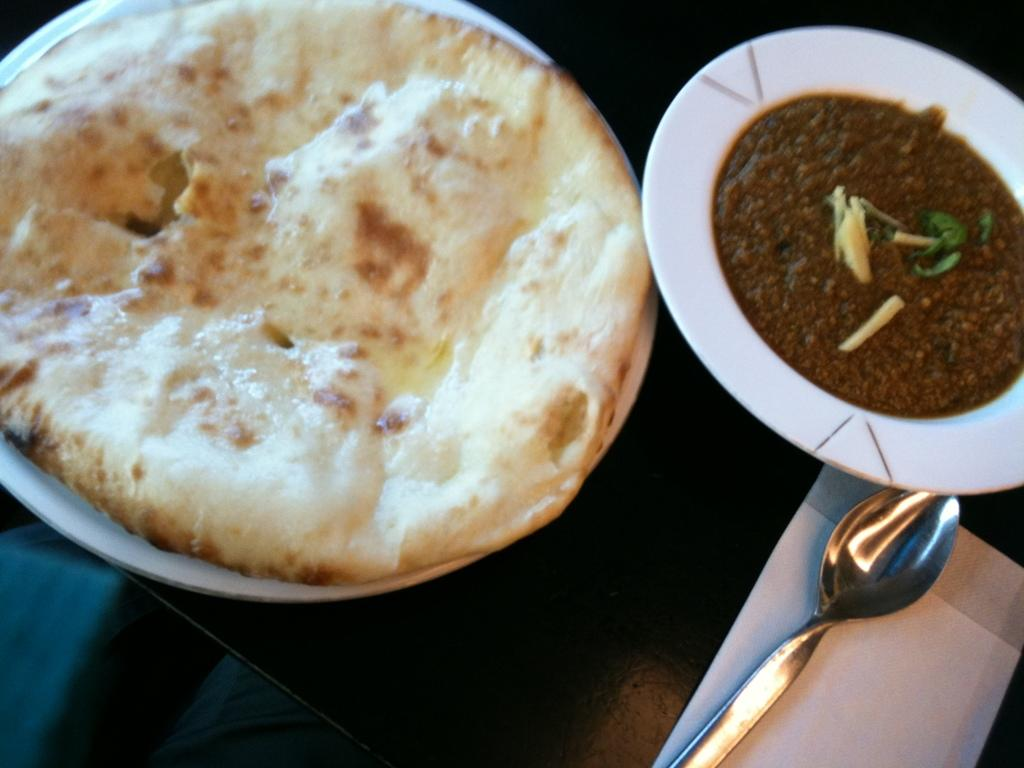What piece of furniture is present in the image? There is a table in the image. What is placed on the table? There is a plate, a bowl, tissue, a spoon, and food items on the table. Can you describe the utensil on the table? There is a spoon on the table. What type of items can be seen on the table? Food items are present on the table. What type of committee is meeting around the table in the image? There is no committee meeting in the image; it only shows a table with various items on it. Can you compare the size of the food items on the table to the size of a bear? There is no bear present in the image, so it is not possible to make a comparison. 